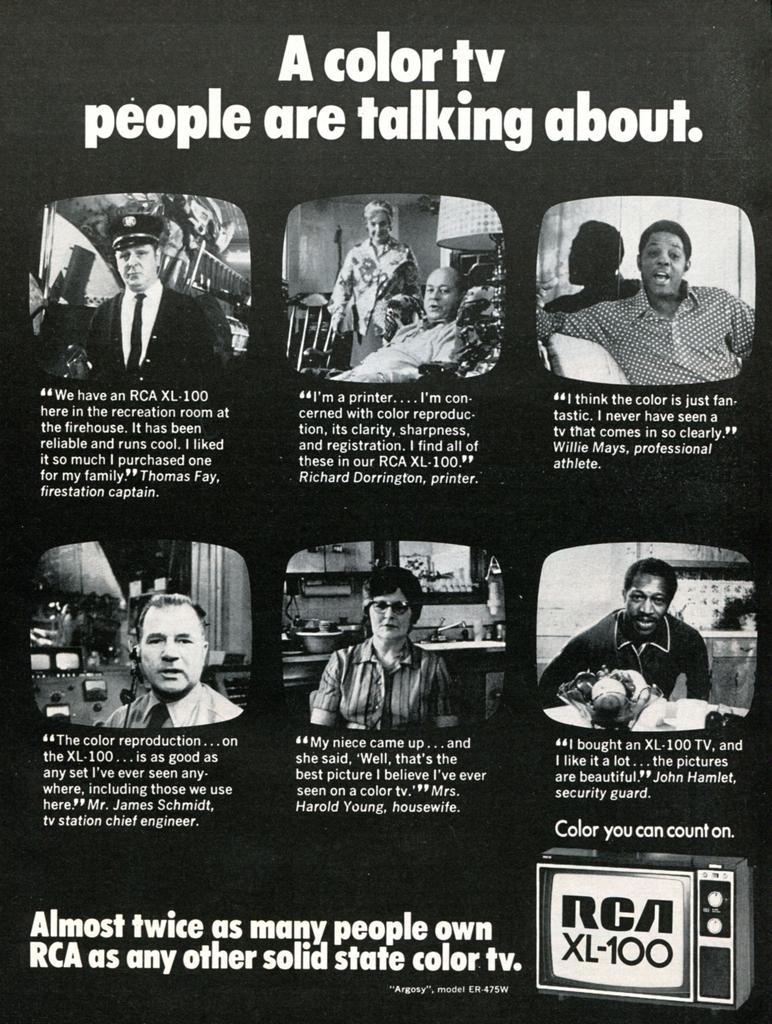What type of image is being described? The image is a collage poster. What can be found within the collage poster? There is text present in the image. What type of insurance is being advertised in the collage poster? There is no insurance being advertised in the image, as it is a collage poster with text but no specific content mentioned. 